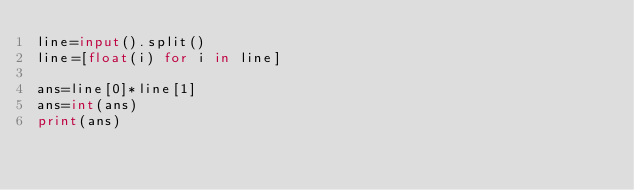Convert code to text. <code><loc_0><loc_0><loc_500><loc_500><_Python_>line=input().split()
line=[float(i) for i in line]

ans=line[0]*line[1]
ans=int(ans)
print(ans)</code> 